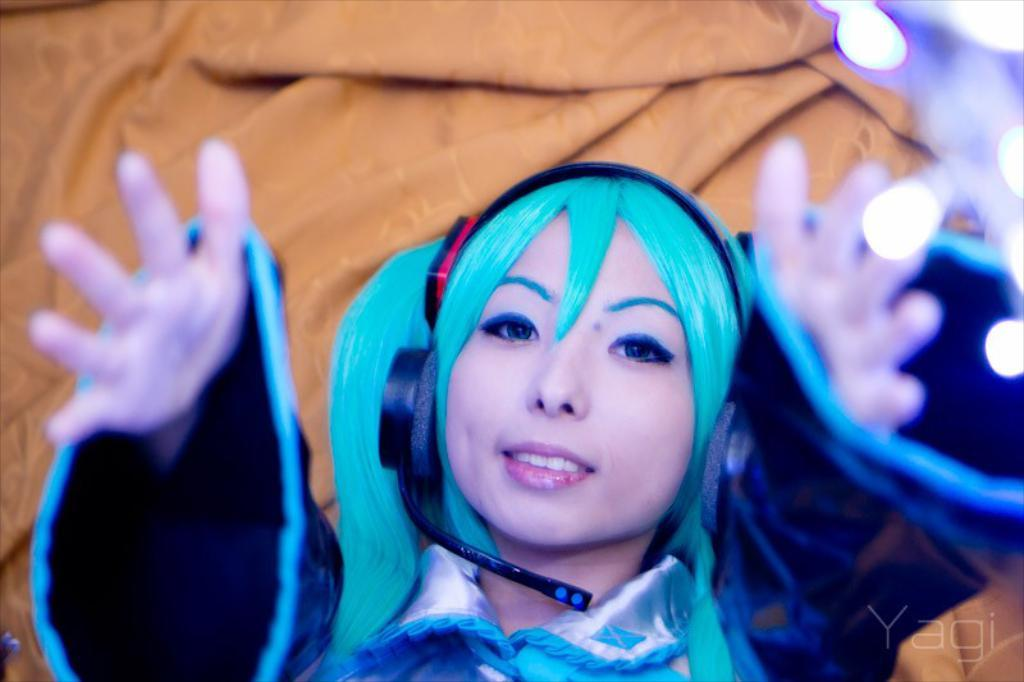Who is the main subject in the image? There is a girl in the image. What is the girl doing in the image? The girl is stretching her arms. What is the girl wearing on her head? The girl is wearing a headset. What substance is the girl using to enhance her stretching in the image? There is no substance visible in the image that the girl is using to enhance her stretching. 